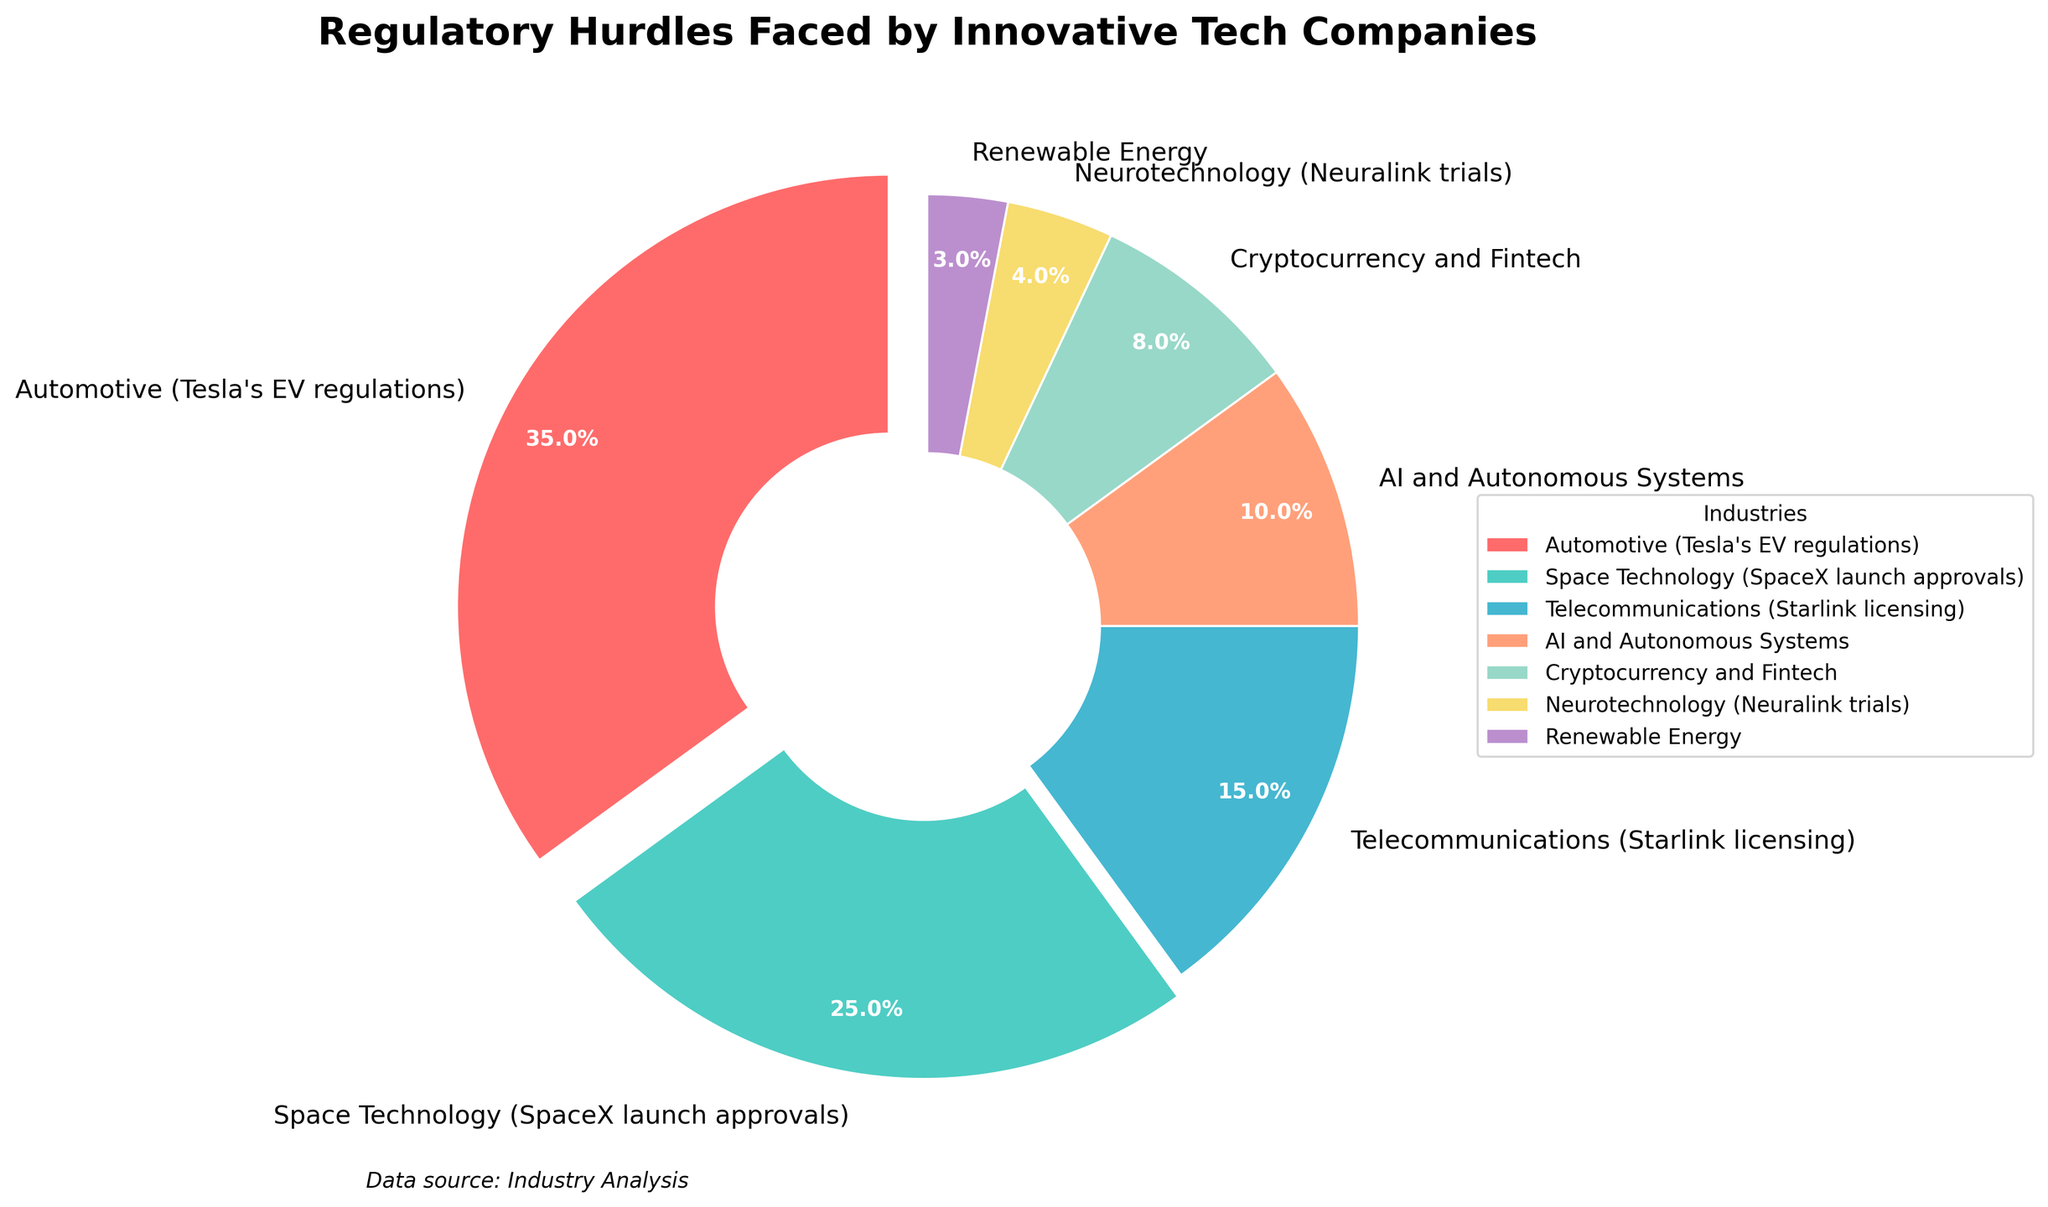What percentage of regulatory hurdles are faced by the Automotive industry? Looking at the pie chart, the Automotive industry (Tesla's EV regulations) slices about 35% of the pie, which is also labeled 35%.
Answer: 35% Which two industries combined have the highest percentage of regulatory hurdles? Combine the Automotive (35%) and Space Technology (25%) industries. The sum is 35% + 25% = 60%, which is highest in the chart.
Answer: Automotive and Space Technology Which industry faces fewer regulatory hurdles: Telecommunications or AI and Autonomous Systems? From the pie chart, Telecommunications is represented by 15% and AI and Autonomous Systems by 10%. Since 10% is less than 15%, AI and Autonomous Systems face fewer hurdles.
Answer: AI and Autonomous Systems What is the percentage difference between Automotive and Renewable Energy regulatory hurdles? The Automotive industry has 35%, while Renewable Energy has 3%. The difference is 35% - 3% = 32%.
Answer: 32% Which color represents the Space Technology industry, and what is its percentage? From the chart, the slice representing Space Technology is in a light blue (cyan-like) color. The percentage labeled next to this slice is 25%.
Answer: Light blue, 25% Among AI and Autonomous Systems, Cryptocurrency and Fintech, and Neurotechnology, which industry faces the lowest regulatory hurdles? The pie chart shows AI and Autonomous Systems (10%), Cryptocurrency and Fintech (8%), and Neurotechnology (4%). Neurotechnology has the smallest value at 4%.
Answer: Neurotechnology How much more significant is the regulatory burden on Space Technology compared to Renewable Energy? Space Technology is shown at 25%, Renewable Energy at 3%. The burden on Space Technology is 25% - 3% = 22% more significant.
Answer: 22% Adding the percentages of the lowest four industries, what is the total regulatory hurdle percentage? The lowest four are Renewable Energy (3%), Neurotechnology (4%), Cryptocurrency and Fintech (8%), and AI and Autonomous Systems (10%). Summing them gives 3% + 4% + 8% + 10% = 25%.
Answer: 25% Which industry faces more regulatory hurdles, Automotive or all industries combined except Automotive? The Automotive industry faces 35%. The total for others is Space Technology (25%) + Telecommunications (15%) + AI and Autonomous Systems (10%) + Cryptocurrency and Fintech (8%) + Neurotechnology (4%) + Renewable Energy (3%) = 65%. 65% is more than 35%.
Answer: All combined except Automotive Arrange all industries in descending order based on the percentage of regulatory hurdles they face. From highest to lowest: Automotive (35%), Space Technology (25%), Telecommunications (15%), AI and Autonomous Systems (10%), Cryptocurrency and Fintech (8%), Neurotechnology (4%), Renewable Energy (3%).
Answer: Automotive, Space Technology, Telecommunications, AI and Autonomous Systems, Cryptocurrency and Fintech, Neurotechnology, Renewable Energy 